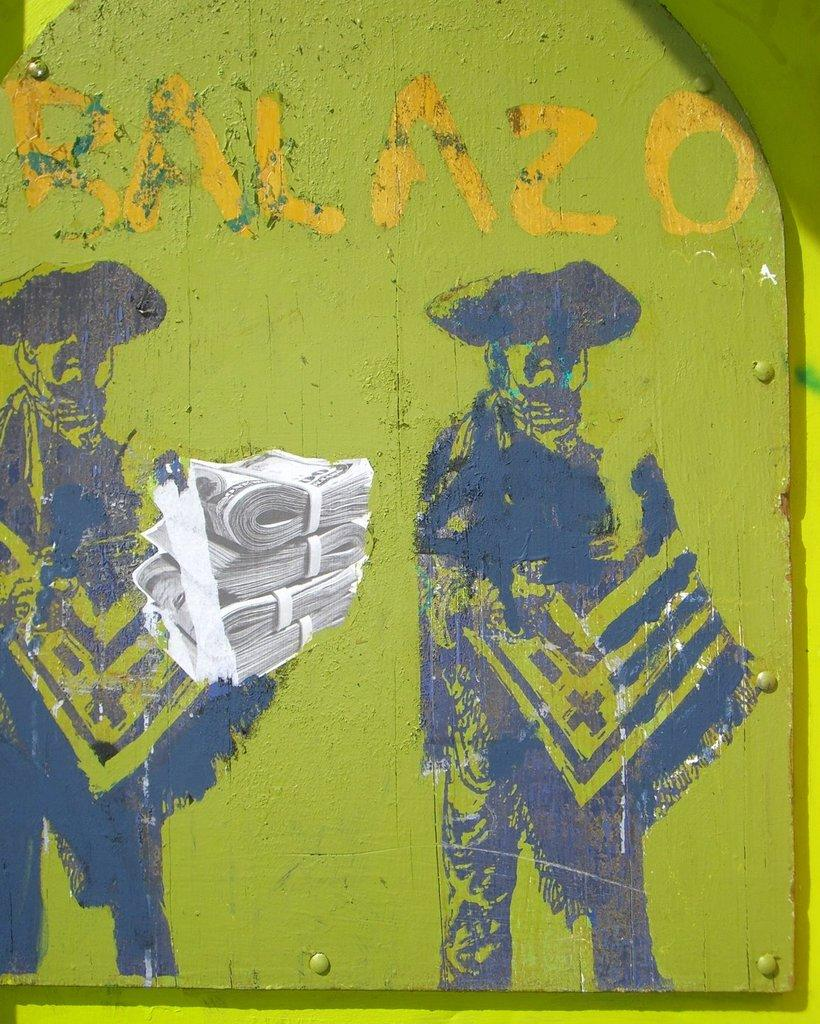What is the primary color of the wooden board in the image? The wooden board in the image is green. What is depicted on the wooden board? The wooden board has some painted craft on it. What reason does the wooden board give for its health issues in the image? The wooden board does not have any health issues, nor does it give any reasons for them, as it is an inanimate object. 